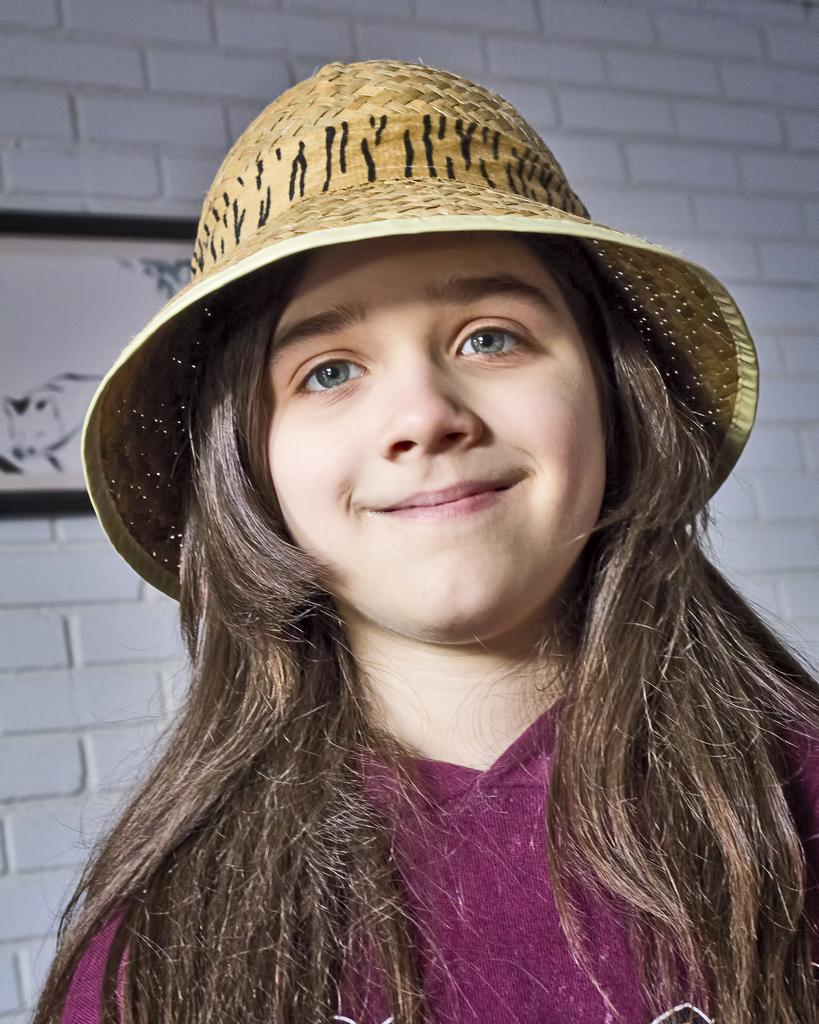Who is the main subject in the image? There is a girl in the image. What is the girl wearing on her head? The girl is wearing a hat. What can be seen on the wall in the background of the image? There is a photo frame on the wall in the background of the image. What advice does the caption on the photo frame give in the image? There is no caption present on the photo frame in the image, so no advice can be given. 